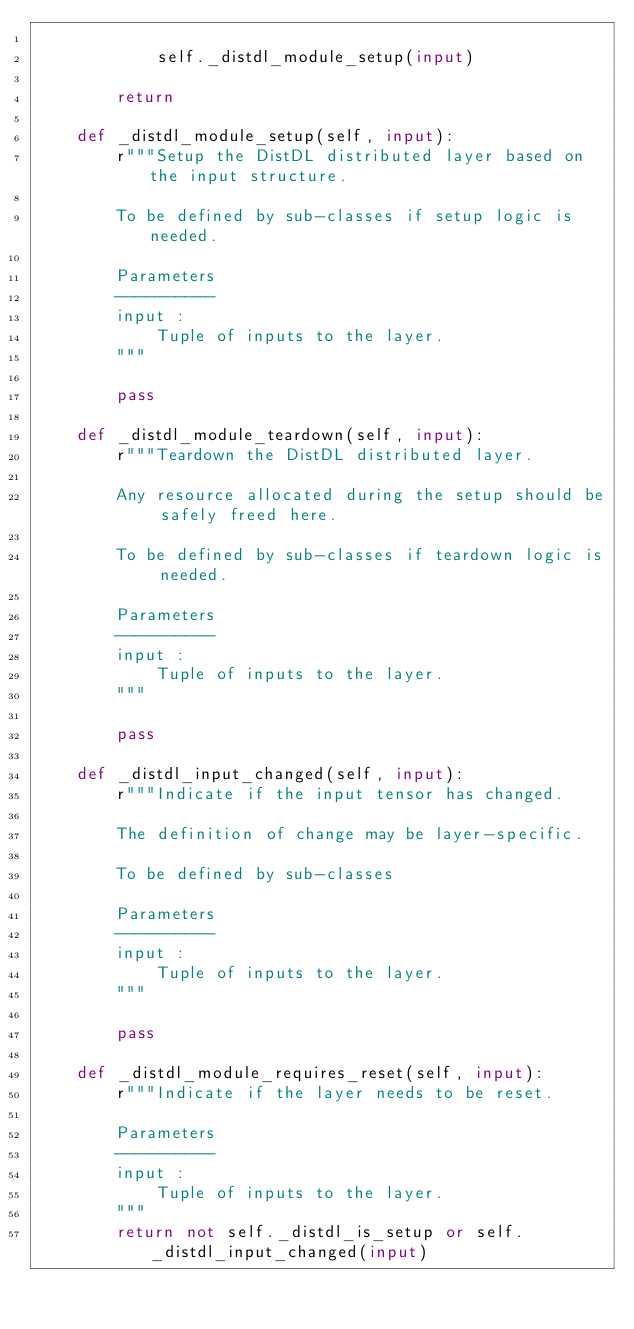Convert code to text. <code><loc_0><loc_0><loc_500><loc_500><_Python_>
            self._distdl_module_setup(input)

        return

    def _distdl_module_setup(self, input):
        r"""Setup the DistDL distributed layer based on the input structure.

        To be defined by sub-classes if setup logic is needed.

        Parameters
        ----------
        input :
            Tuple of inputs to the layer.
        """

        pass

    def _distdl_module_teardown(self, input):
        r"""Teardown the DistDL distributed layer.

        Any resource allocated during the setup should be safely freed here.

        To be defined by sub-classes if teardown logic is needed.

        Parameters
        ----------
        input :
            Tuple of inputs to the layer.
        """

        pass

    def _distdl_input_changed(self, input):
        r"""Indicate if the input tensor has changed.

        The definition of change may be layer-specific.

        To be defined by sub-classes

        Parameters
        ----------
        input :
            Tuple of inputs to the layer.
        """

        pass

    def _distdl_module_requires_reset(self, input):
        r"""Indicate if the layer needs to be reset.

        Parameters
        ----------
        input :
            Tuple of inputs to the layer.
        """
        return not self._distdl_is_setup or self._distdl_input_changed(input)
</code> 